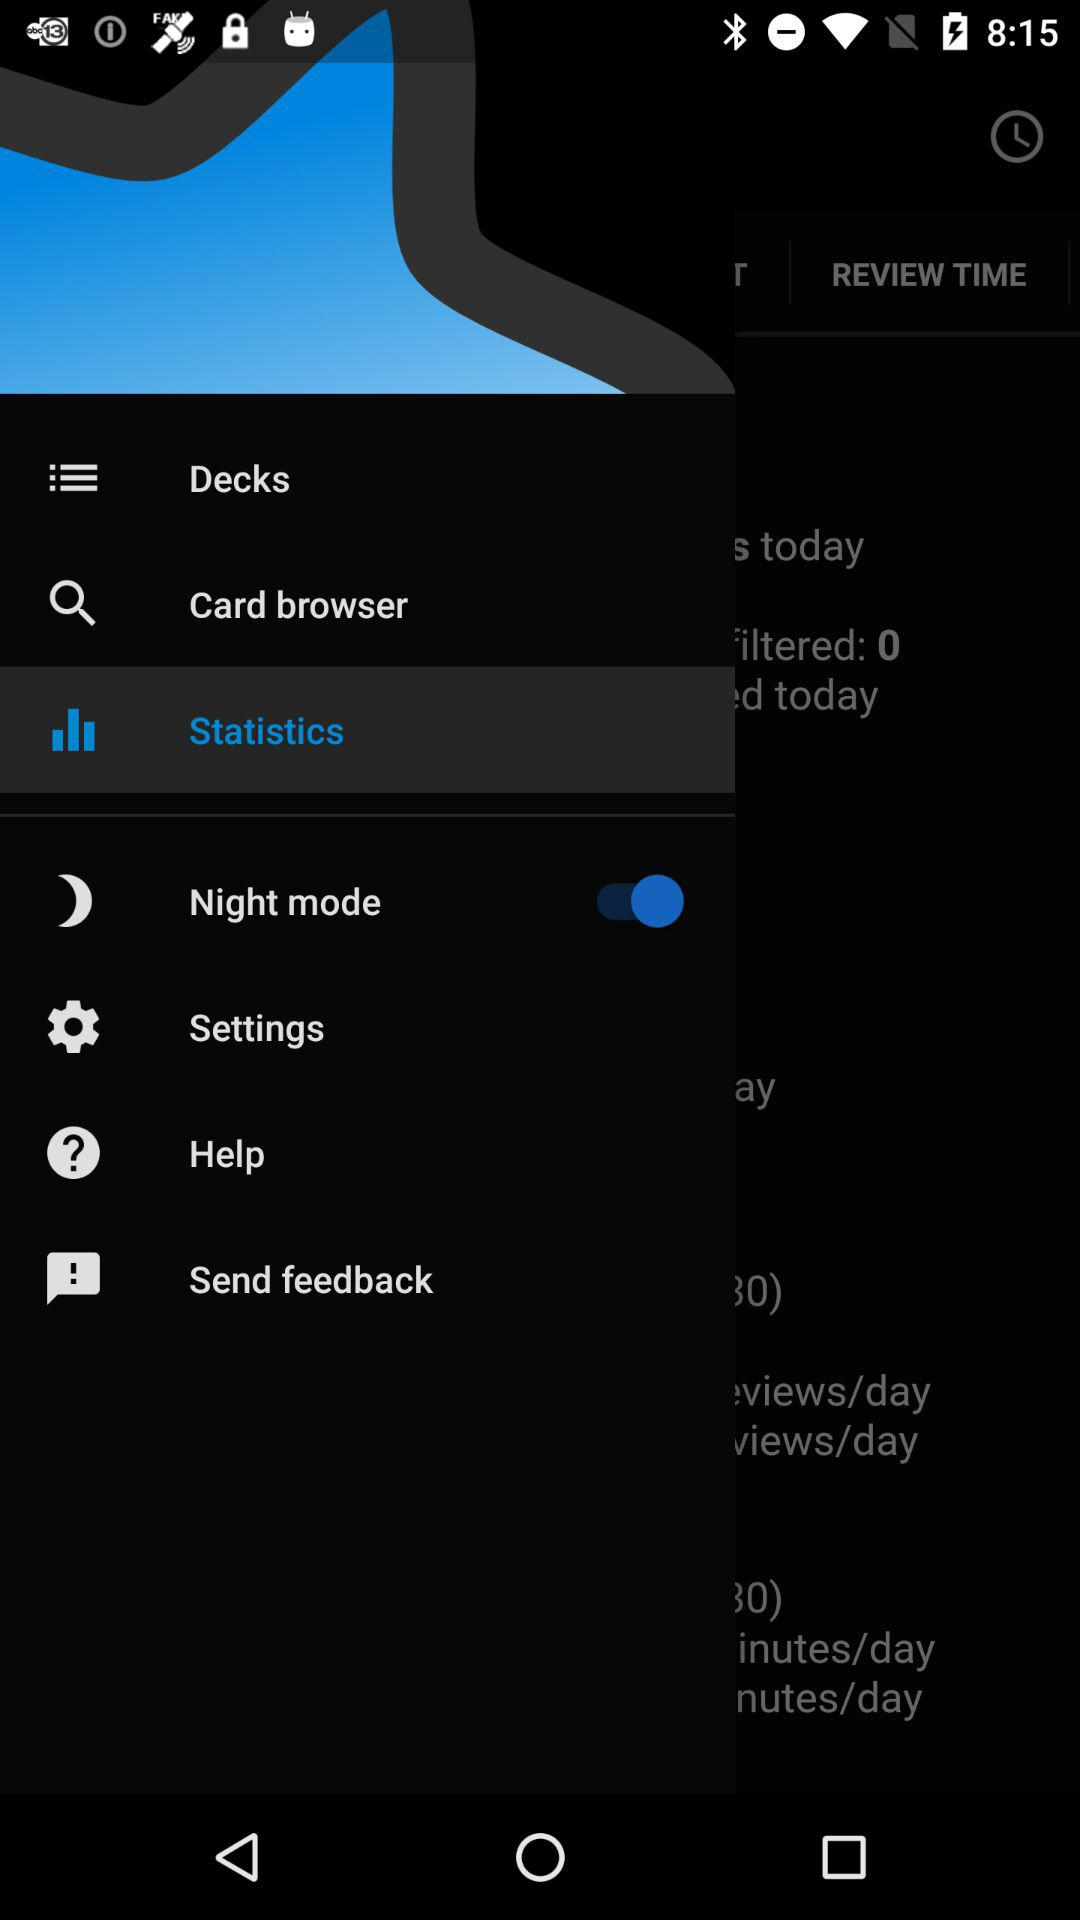Which statistics are displayed on the screen?
When the provided information is insufficient, respond with <no answer>. <no answer> 